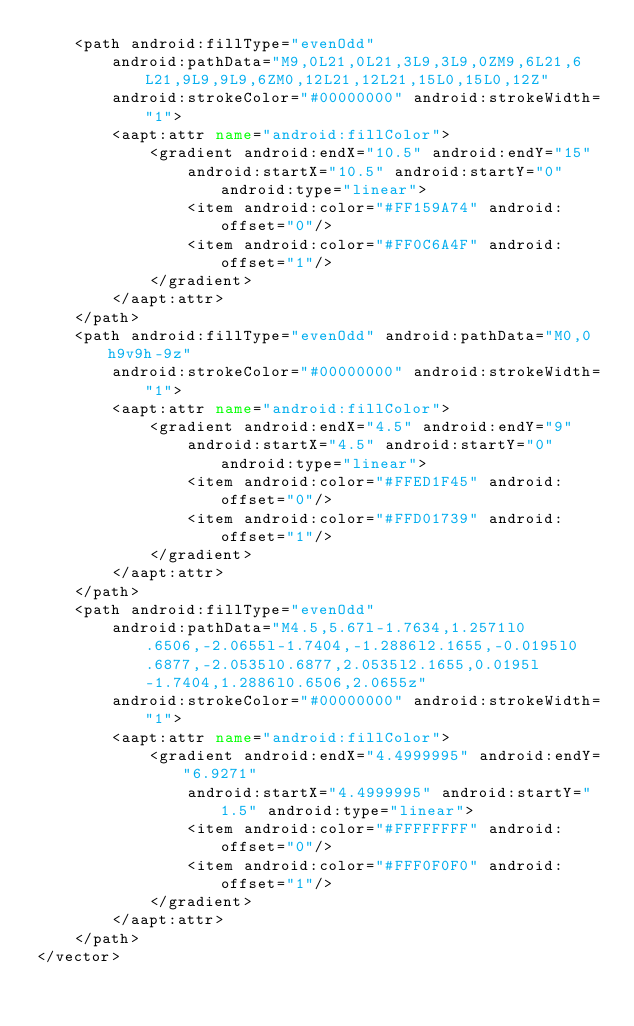Convert code to text. <code><loc_0><loc_0><loc_500><loc_500><_XML_>    <path android:fillType="evenOdd"
        android:pathData="M9,0L21,0L21,3L9,3L9,0ZM9,6L21,6L21,9L9,9L9,6ZM0,12L21,12L21,15L0,15L0,12Z"
        android:strokeColor="#00000000" android:strokeWidth="1">
        <aapt:attr name="android:fillColor">
            <gradient android:endX="10.5" android:endY="15"
                android:startX="10.5" android:startY="0" android:type="linear">
                <item android:color="#FF159A74" android:offset="0"/>
                <item android:color="#FF0C6A4F" android:offset="1"/>
            </gradient>
        </aapt:attr>
    </path>
    <path android:fillType="evenOdd" android:pathData="M0,0h9v9h-9z"
        android:strokeColor="#00000000" android:strokeWidth="1">
        <aapt:attr name="android:fillColor">
            <gradient android:endX="4.5" android:endY="9"
                android:startX="4.5" android:startY="0" android:type="linear">
                <item android:color="#FFED1F45" android:offset="0"/>
                <item android:color="#FFD01739" android:offset="1"/>
            </gradient>
        </aapt:attr>
    </path>
    <path android:fillType="evenOdd"
        android:pathData="M4.5,5.67l-1.7634,1.2571l0.6506,-2.0655l-1.7404,-1.2886l2.1655,-0.0195l0.6877,-2.0535l0.6877,2.0535l2.1655,0.0195l-1.7404,1.2886l0.6506,2.0655z"
        android:strokeColor="#00000000" android:strokeWidth="1">
        <aapt:attr name="android:fillColor">
            <gradient android:endX="4.4999995" android:endY="6.9271"
                android:startX="4.4999995" android:startY="1.5" android:type="linear">
                <item android:color="#FFFFFFFF" android:offset="0"/>
                <item android:color="#FFF0F0F0" android:offset="1"/>
            </gradient>
        </aapt:attr>
    </path>
</vector>
</code> 